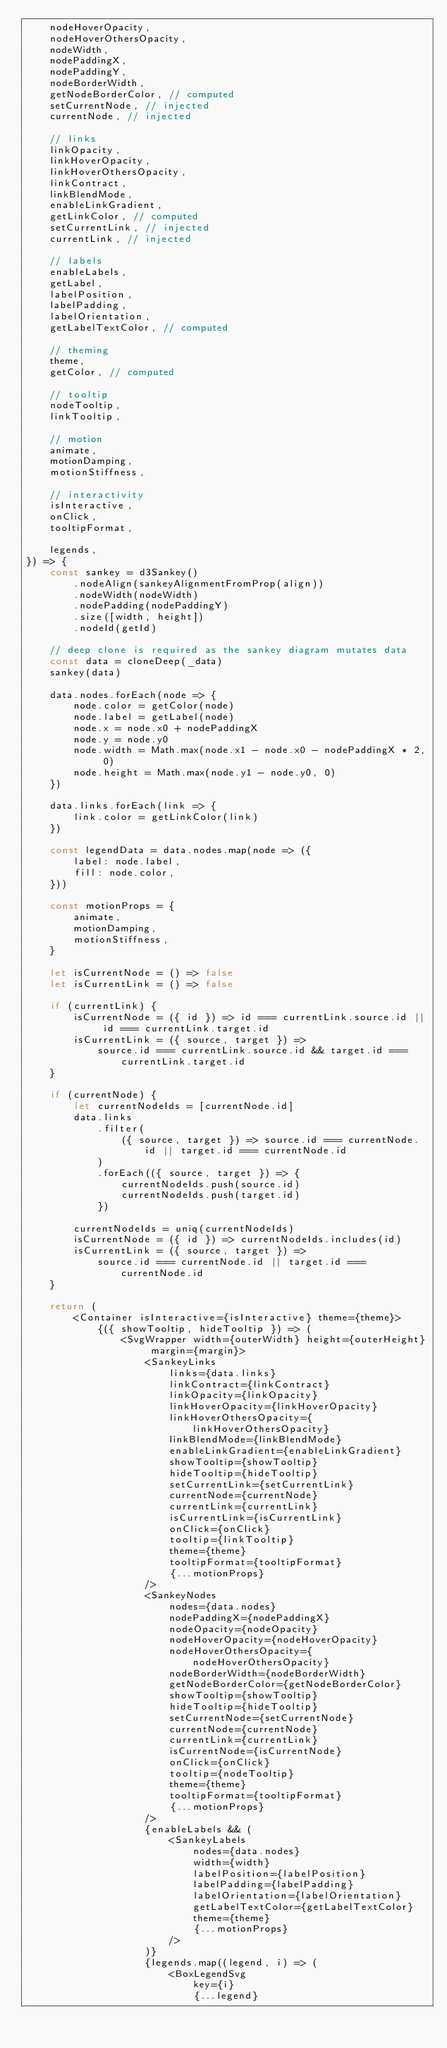Convert code to text. <code><loc_0><loc_0><loc_500><loc_500><_JavaScript_>    nodeHoverOpacity,
    nodeHoverOthersOpacity,
    nodeWidth,
    nodePaddingX,
    nodePaddingY,
    nodeBorderWidth,
    getNodeBorderColor, // computed
    setCurrentNode, // injected
    currentNode, // injected

    // links
    linkOpacity,
    linkHoverOpacity,
    linkHoverOthersOpacity,
    linkContract,
    linkBlendMode,
    enableLinkGradient,
    getLinkColor, // computed
    setCurrentLink, // injected
    currentLink, // injected

    // labels
    enableLabels,
    getLabel,
    labelPosition,
    labelPadding,
    labelOrientation,
    getLabelTextColor, // computed

    // theming
    theme,
    getColor, // computed

    // tooltip
    nodeTooltip,
    linkTooltip,

    // motion
    animate,
    motionDamping,
    motionStiffness,

    // interactivity
    isInteractive,
    onClick,
    tooltipFormat,

    legends,
}) => {
    const sankey = d3Sankey()
        .nodeAlign(sankeyAlignmentFromProp(align))
        .nodeWidth(nodeWidth)
        .nodePadding(nodePaddingY)
        .size([width, height])
        .nodeId(getId)

    // deep clone is required as the sankey diagram mutates data
    const data = cloneDeep(_data)
    sankey(data)

    data.nodes.forEach(node => {
        node.color = getColor(node)
        node.label = getLabel(node)
        node.x = node.x0 + nodePaddingX
        node.y = node.y0
        node.width = Math.max(node.x1 - node.x0 - nodePaddingX * 2, 0)
        node.height = Math.max(node.y1 - node.y0, 0)
    })

    data.links.forEach(link => {
        link.color = getLinkColor(link)
    })

    const legendData = data.nodes.map(node => ({
        label: node.label,
        fill: node.color,
    }))

    const motionProps = {
        animate,
        motionDamping,
        motionStiffness,
    }

    let isCurrentNode = () => false
    let isCurrentLink = () => false

    if (currentLink) {
        isCurrentNode = ({ id }) => id === currentLink.source.id || id === currentLink.target.id
        isCurrentLink = ({ source, target }) =>
            source.id === currentLink.source.id && target.id === currentLink.target.id
    }

    if (currentNode) {
        let currentNodeIds = [currentNode.id]
        data.links
            .filter(
                ({ source, target }) => source.id === currentNode.id || target.id === currentNode.id
            )
            .forEach(({ source, target }) => {
                currentNodeIds.push(source.id)
                currentNodeIds.push(target.id)
            })

        currentNodeIds = uniq(currentNodeIds)
        isCurrentNode = ({ id }) => currentNodeIds.includes(id)
        isCurrentLink = ({ source, target }) =>
            source.id === currentNode.id || target.id === currentNode.id
    }

    return (
        <Container isInteractive={isInteractive} theme={theme}>
            {({ showTooltip, hideTooltip }) => (
                <SvgWrapper width={outerWidth} height={outerHeight} margin={margin}>
                    <SankeyLinks
                        links={data.links}
                        linkContract={linkContract}
                        linkOpacity={linkOpacity}
                        linkHoverOpacity={linkHoverOpacity}
                        linkHoverOthersOpacity={linkHoverOthersOpacity}
                        linkBlendMode={linkBlendMode}
                        enableLinkGradient={enableLinkGradient}
                        showTooltip={showTooltip}
                        hideTooltip={hideTooltip}
                        setCurrentLink={setCurrentLink}
                        currentNode={currentNode}
                        currentLink={currentLink}
                        isCurrentLink={isCurrentLink}
                        onClick={onClick}
                        tooltip={linkTooltip}
                        theme={theme}
                        tooltipFormat={tooltipFormat}
                        {...motionProps}
                    />
                    <SankeyNodes
                        nodes={data.nodes}
                        nodePaddingX={nodePaddingX}
                        nodeOpacity={nodeOpacity}
                        nodeHoverOpacity={nodeHoverOpacity}
                        nodeHoverOthersOpacity={nodeHoverOthersOpacity}
                        nodeBorderWidth={nodeBorderWidth}
                        getNodeBorderColor={getNodeBorderColor}
                        showTooltip={showTooltip}
                        hideTooltip={hideTooltip}
                        setCurrentNode={setCurrentNode}
                        currentNode={currentNode}
                        currentLink={currentLink}
                        isCurrentNode={isCurrentNode}
                        onClick={onClick}
                        tooltip={nodeTooltip}
                        theme={theme}
                        tooltipFormat={tooltipFormat}
                        {...motionProps}
                    />
                    {enableLabels && (
                        <SankeyLabels
                            nodes={data.nodes}
                            width={width}
                            labelPosition={labelPosition}
                            labelPadding={labelPadding}
                            labelOrientation={labelOrientation}
                            getLabelTextColor={getLabelTextColor}
                            theme={theme}
                            {...motionProps}
                        />
                    )}
                    {legends.map((legend, i) => (
                        <BoxLegendSvg
                            key={i}
                            {...legend}</code> 